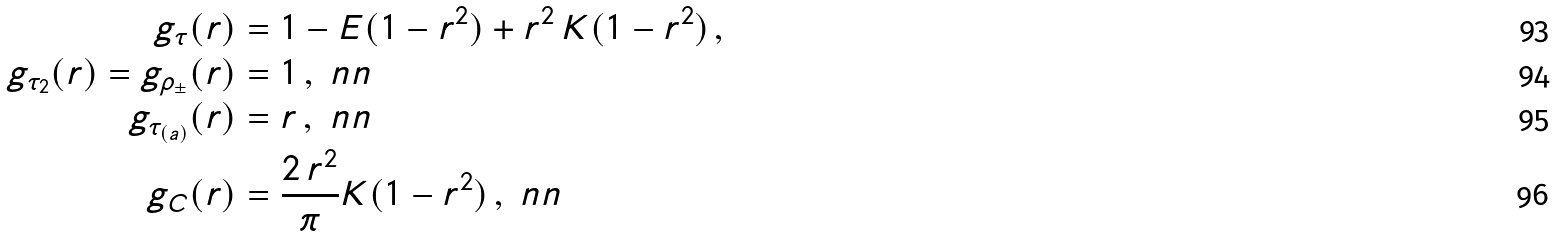<formula> <loc_0><loc_0><loc_500><loc_500>g _ { \tau } ( r ) & = 1 - E ( 1 - r ^ { 2 } ) + r ^ { 2 } \, K ( 1 - r ^ { 2 } ) \, , \\ g _ { \tau _ { 2 } } ( r ) = g _ { \rho _ { \pm } } ( r ) & = 1 \, , \ n n \\ g _ { \tau _ { ( a ) } } ( r ) & = r \, , \ n n \\ g _ { C } ( r ) & = \frac { 2 \, r ^ { 2 } } { \pi } K ( 1 - r ^ { 2 } ) \, , \ n n</formula> 